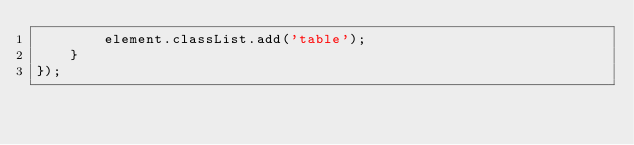<code> <loc_0><loc_0><loc_500><loc_500><_JavaScript_>        element.classList.add('table');
    }
});
</code> 